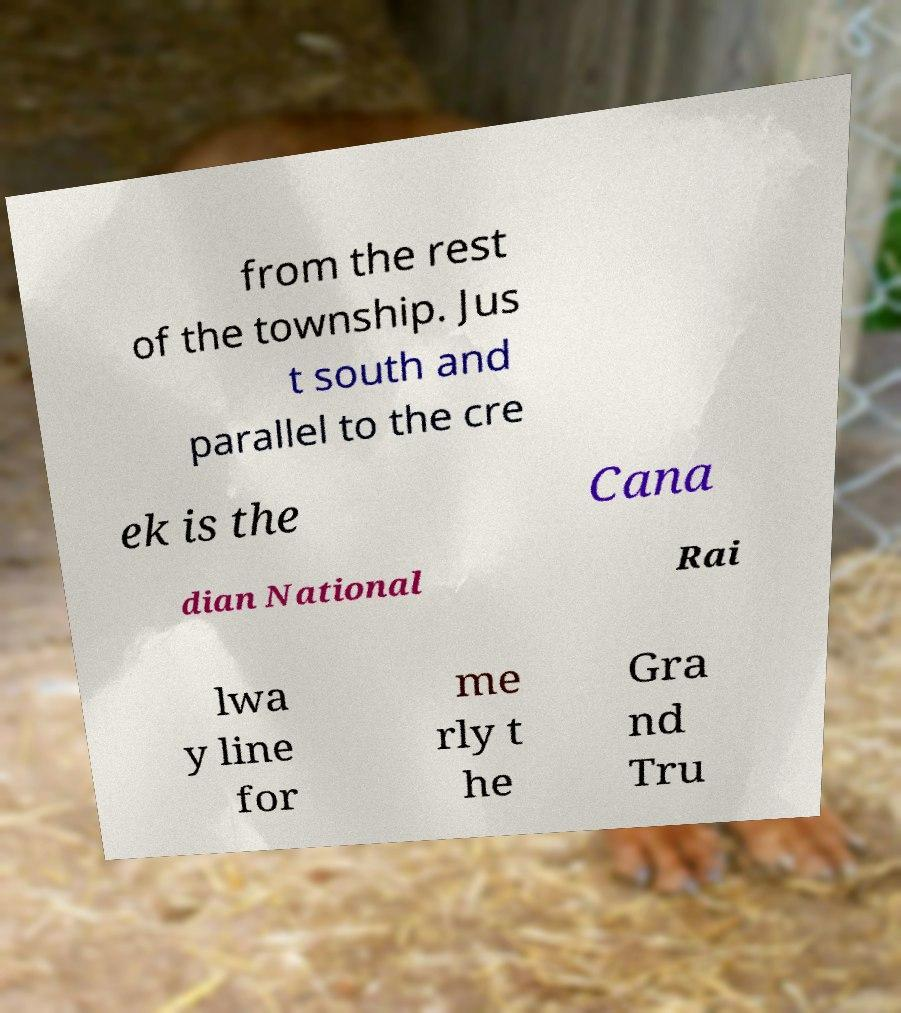Can you accurately transcribe the text from the provided image for me? from the rest of the township. Jus t south and parallel to the cre ek is the Cana dian National Rai lwa y line for me rly t he Gra nd Tru 